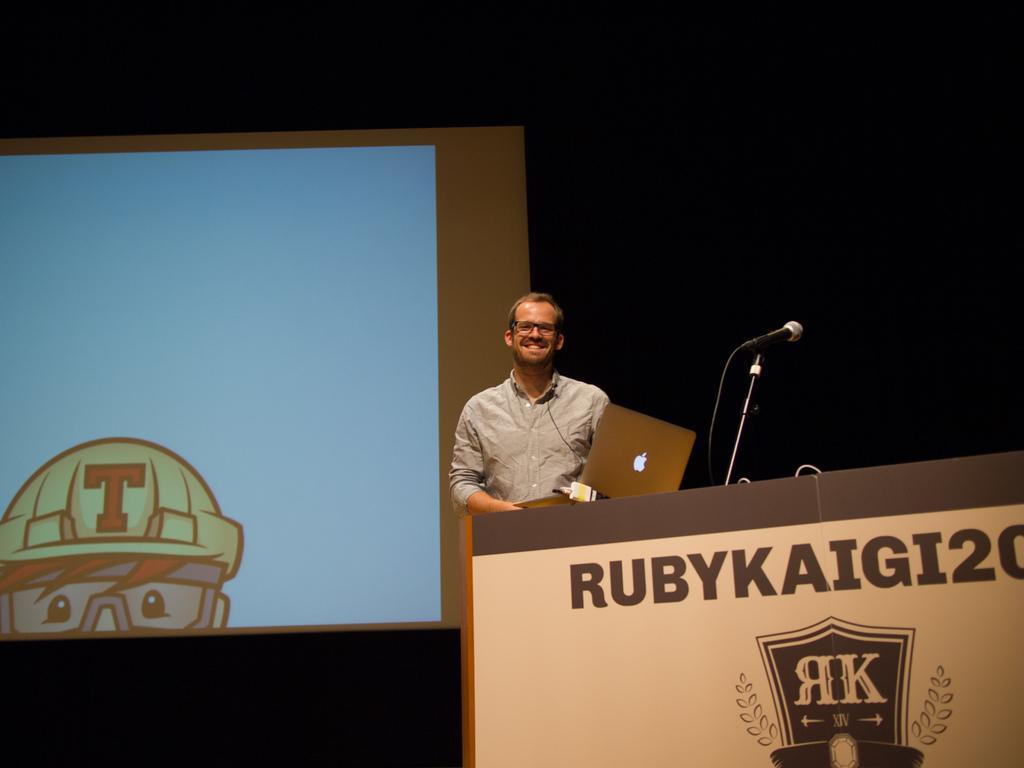In one or two sentences, can you explain what this image depicts? In the center of the image there is a person standing near a podium. There is a laptop. In the background of the image there is a screen. 